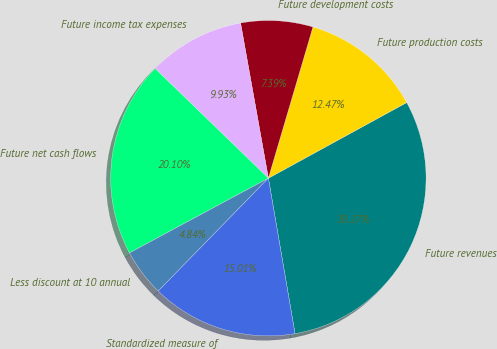Convert chart to OTSL. <chart><loc_0><loc_0><loc_500><loc_500><pie_chart><fcel>Future revenues<fcel>Future production costs<fcel>Future development costs<fcel>Future income tax expenses<fcel>Future net cash flows<fcel>Less discount at 10 annual<fcel>Standardized measure of<nl><fcel>30.27%<fcel>12.47%<fcel>7.39%<fcel>9.93%<fcel>20.1%<fcel>4.84%<fcel>15.01%<nl></chart> 